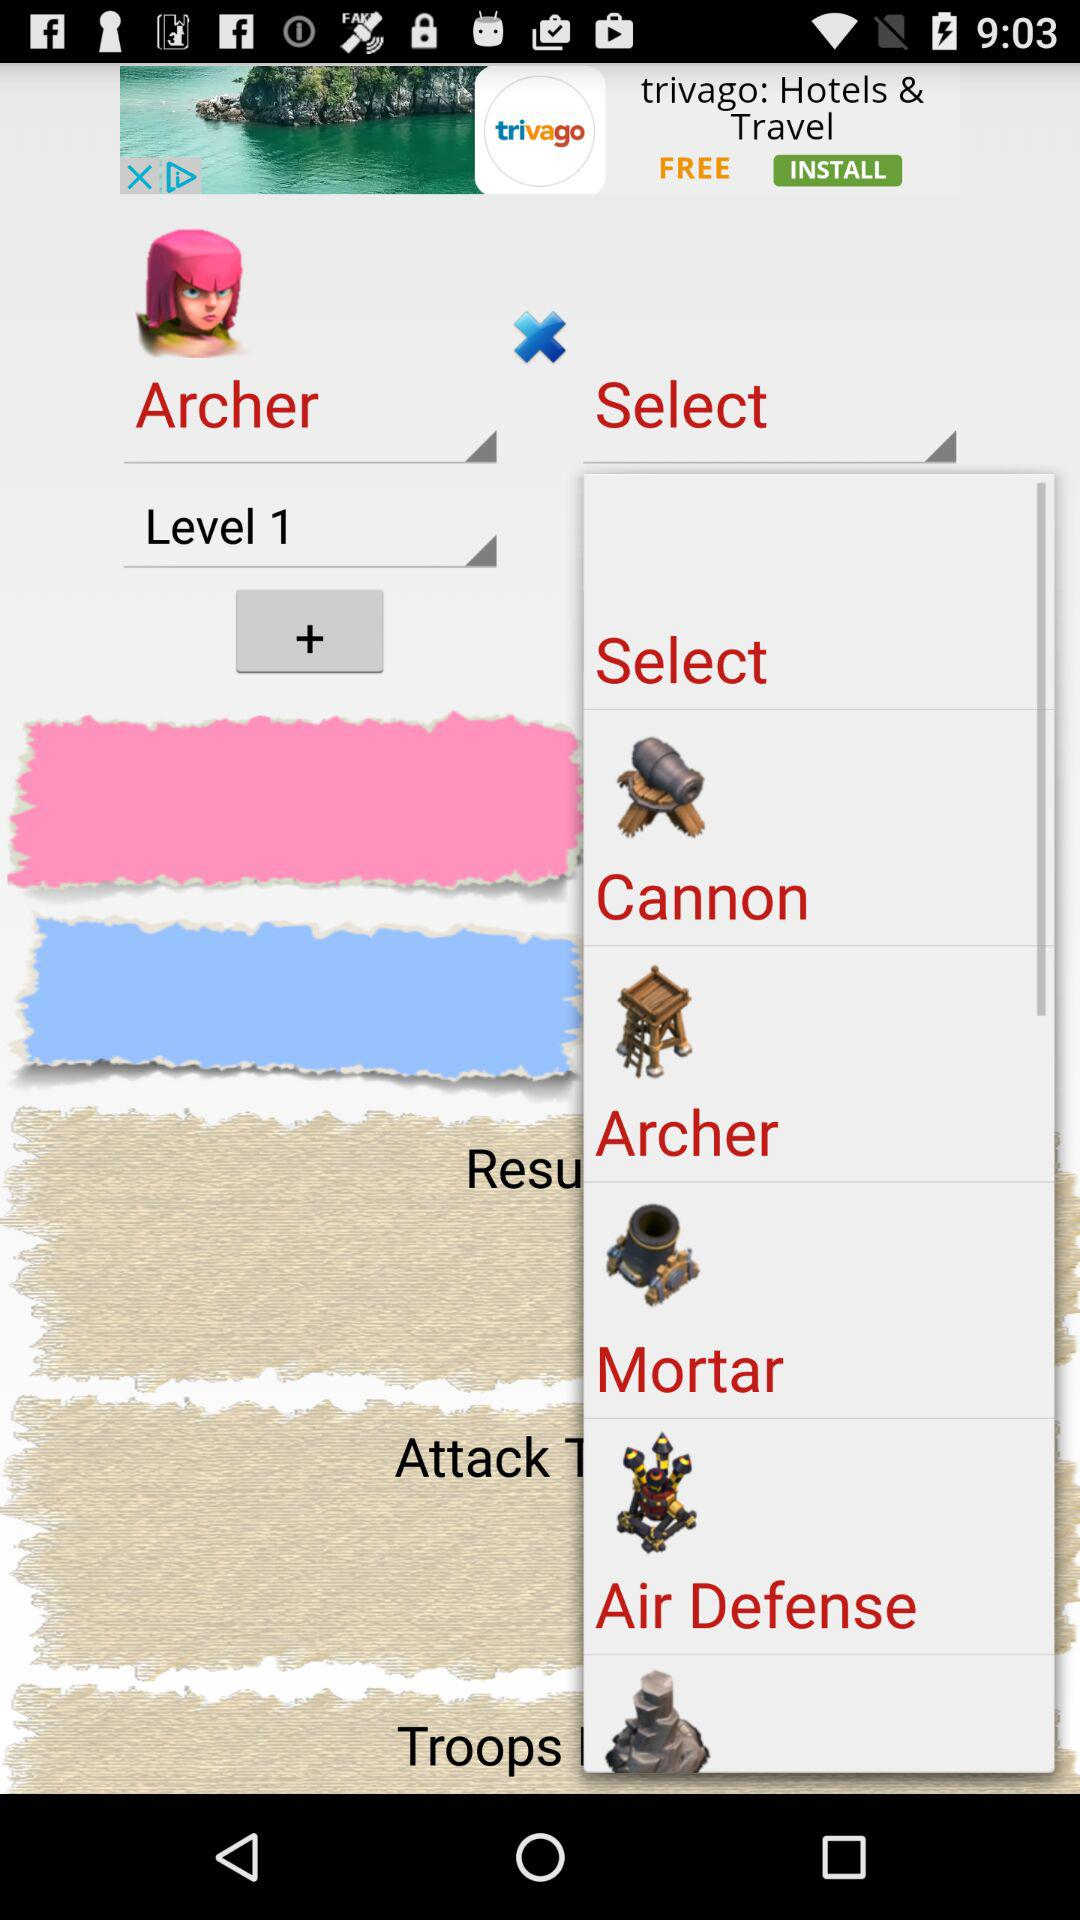Which level is selected? The selected level is 1. 